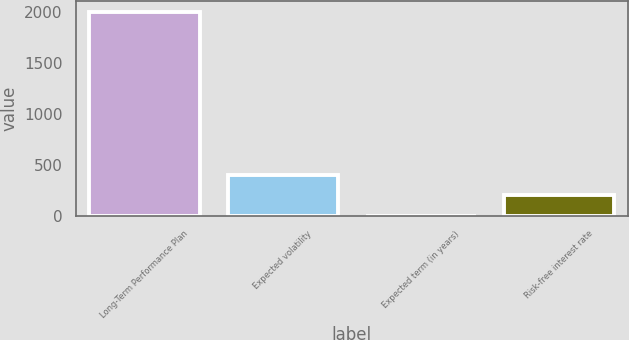Convert chart. <chart><loc_0><loc_0><loc_500><loc_500><bar_chart><fcel>Long-Term Performance Plan<fcel>Expected volatility<fcel>Expected term (in years)<fcel>Risk-free interest rate<nl><fcel>2007<fcel>403<fcel>2<fcel>202.5<nl></chart> 